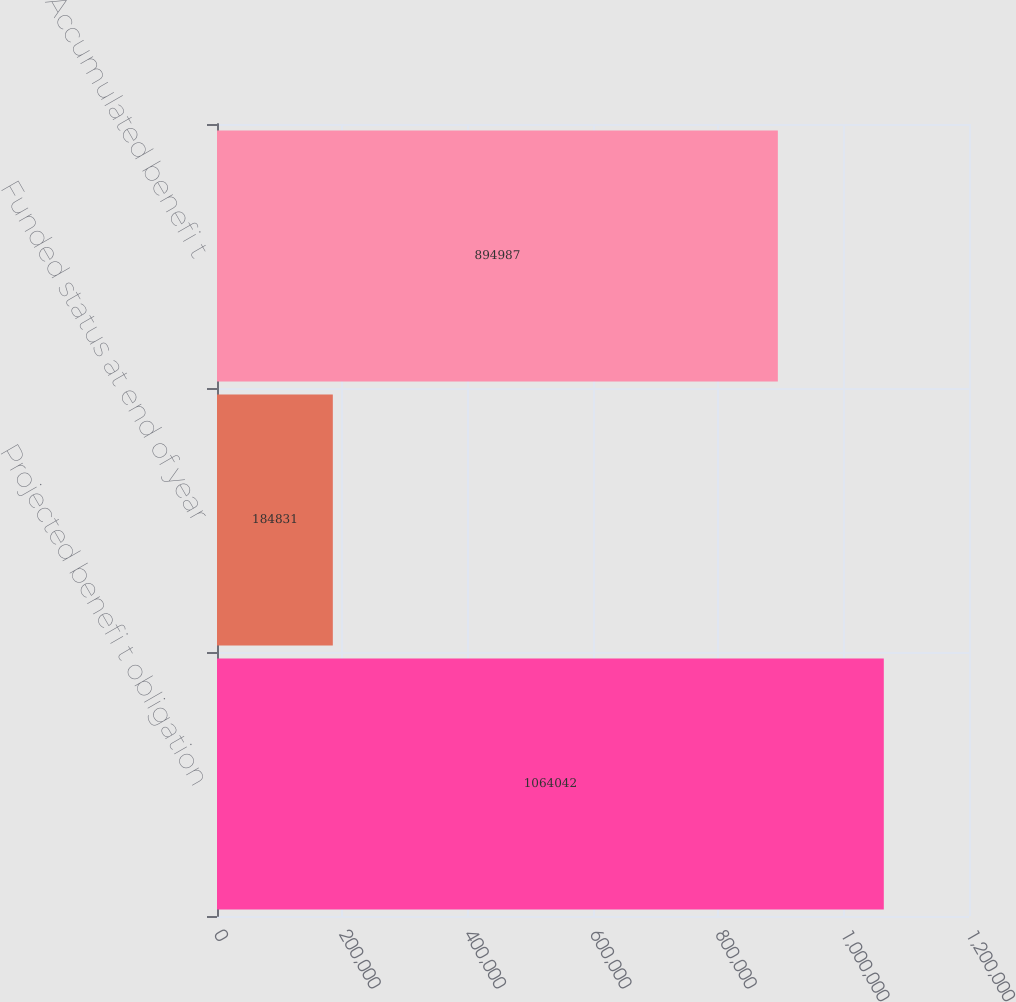Convert chart. <chart><loc_0><loc_0><loc_500><loc_500><bar_chart><fcel>Projected benefi t obligation<fcel>Funded status at end of year<fcel>Accumulated benefi t<nl><fcel>1.06404e+06<fcel>184831<fcel>894987<nl></chart> 